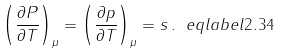Convert formula to latex. <formula><loc_0><loc_0><loc_500><loc_500>\left ( \frac { \partial P } { \partial T } \right ) _ { \mu } = \left ( \frac { \partial p } { \partial T } \right ) _ { \mu } = s \, . \ e q l a b e l { 2 . 3 4 }</formula> 